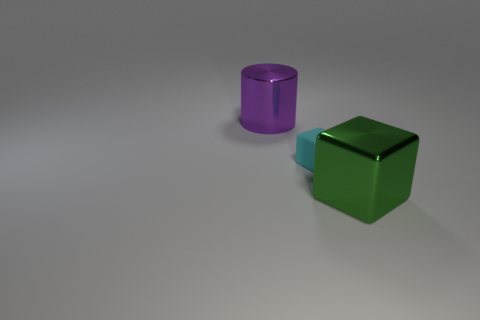How many other big shiny objects are the same shape as the green metal object? 0 